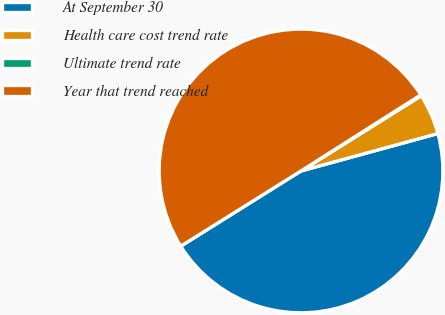<chart> <loc_0><loc_0><loc_500><loc_500><pie_chart><fcel>At September 30<fcel>Health care cost trend rate<fcel>Ultimate trend rate<fcel>Year that trend reached<nl><fcel>45.35%<fcel>4.65%<fcel>0.11%<fcel>49.89%<nl></chart> 